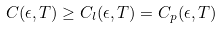Convert formula to latex. <formula><loc_0><loc_0><loc_500><loc_500>C ( \epsilon , T ) \geq C _ { l } ( \epsilon , T ) = C _ { p } ( \epsilon , T )</formula> 